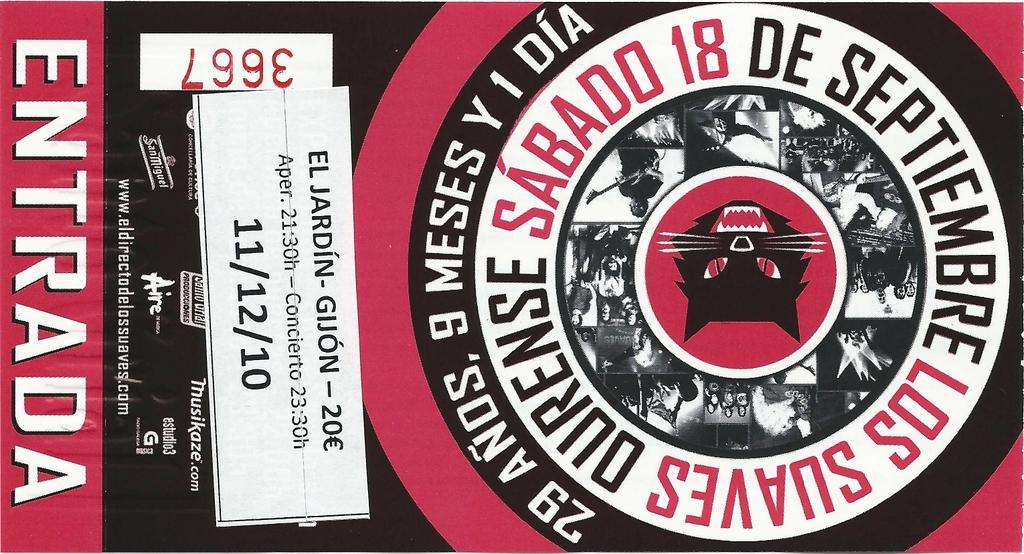<image>
Share a concise interpretation of the image provided. A poster advertises a show which took place on 11/12/10. 